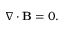<formula> <loc_0><loc_0><loc_500><loc_500>\nabla \cdot B = 0 .</formula> 